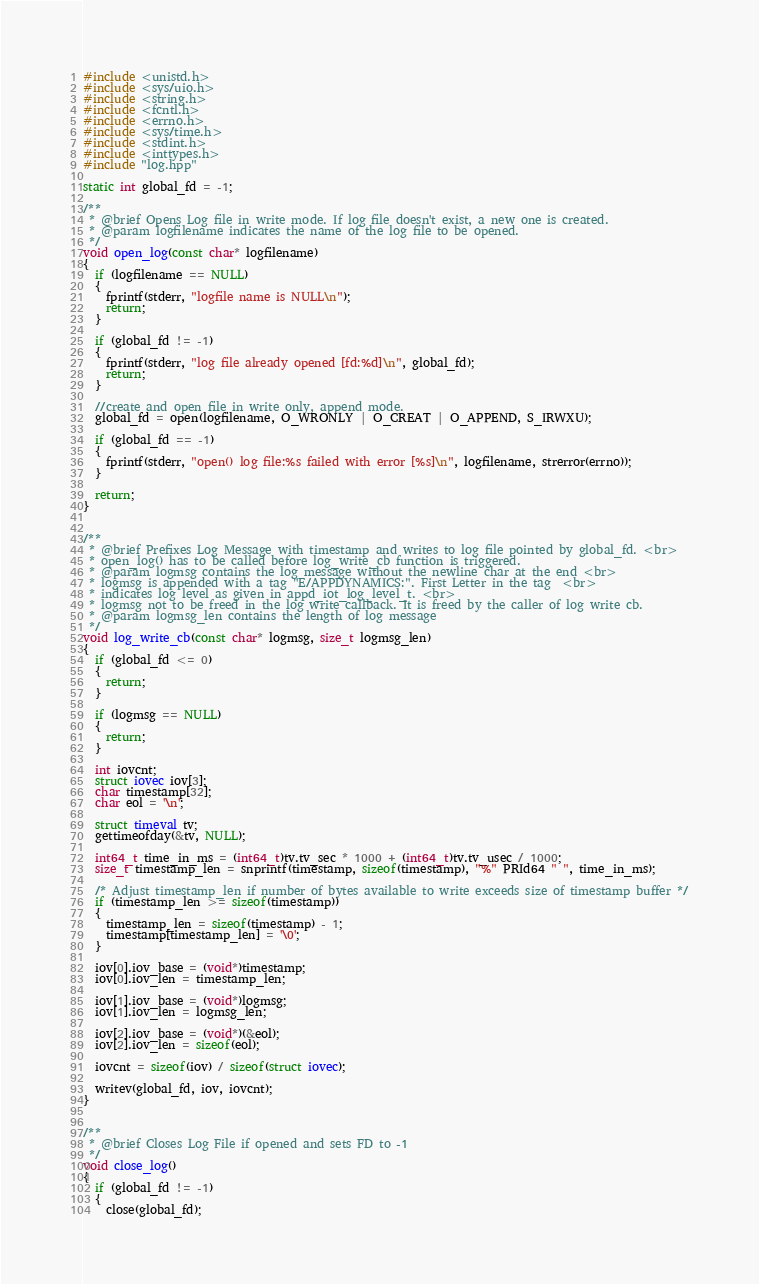Convert code to text. <code><loc_0><loc_0><loc_500><loc_500><_C++_>#include <unistd.h>
#include <sys/uio.h>
#include <string.h>
#include <fcntl.h>
#include <errno.h>
#include <sys/time.h>
#include <stdint.h>
#include <inttypes.h>
#include "log.hpp"

static int global_fd = -1;

/**
 * @brief Opens Log file in write mode. If log file doesn't exist, a new one is created.
 * @param logfilename indicates the name of the log file to be opened.
 */
void open_log(const char* logfilename)
{
  if (logfilename == NULL)
  {
    fprintf(stderr, "logfile name is NULL\n");
    return;
  }

  if (global_fd != -1)
  {
    fprintf(stderr, "log file already opened [fd:%d]\n", global_fd);
    return;
  }

  //create and open file in write only, append mode.
  global_fd = open(logfilename, O_WRONLY | O_CREAT | O_APPEND, S_IRWXU);

  if (global_fd == -1)
  {
    fprintf(stderr, "open() log file:%s failed with error [%s]\n", logfilename, strerror(errno));
  }

  return;
}


/**
 * @brief Prefixes Log Message with timestamp and writes to log file pointed by global_fd. <br>
 * open_log() has to be called before log_write_cb function is triggered.
 * @param logmsg contains the log message without the newline char at the end <br>
 * logmsg is appended with a tag "E/APPDYNAMICS:". First Letter in the tag  <br>
 * indicates log level as given in appd_iot_log_level_t. <br>
 * logmsg not to be freed in the log write callback. It is freed by the caller of log write cb.
 * @param logmsg_len contains the length of log message
 */
void log_write_cb(const char* logmsg, size_t logmsg_len)
{
  if (global_fd <= 0)
  {
    return;
  }

  if (logmsg == NULL)
  {
    return;
  }

  int iovcnt;
  struct iovec iov[3];
  char timestamp[32];
  char eol = '\n';

  struct timeval tv;
  gettimeofday(&tv, NULL);

  int64_t time_in_ms = (int64_t)tv.tv_sec * 1000 + (int64_t)tv.tv_usec / 1000;
  size_t timestamp_len = snprintf(timestamp, sizeof(timestamp), "%" PRId64 " ", time_in_ms);

  /* Adjust timestamp_len if number of bytes available to write exceeds size of timestamp buffer */
  if (timestamp_len >= sizeof(timestamp))
  {
    timestamp_len = sizeof(timestamp) - 1;
    timestamp[timestamp_len] = '\0';
  }

  iov[0].iov_base = (void*)timestamp;
  iov[0].iov_len = timestamp_len;

  iov[1].iov_base = (void*)logmsg;
  iov[1].iov_len = logmsg_len;

  iov[2].iov_base = (void*)(&eol);
  iov[2].iov_len = sizeof(eol);

  iovcnt = sizeof(iov) / sizeof(struct iovec);

  writev(global_fd, iov, iovcnt);
}


/**
 * @brief Closes Log File if opened and sets FD to -1
 */
void close_log()
{
  if (global_fd != -1)
  {
    close(global_fd);</code> 